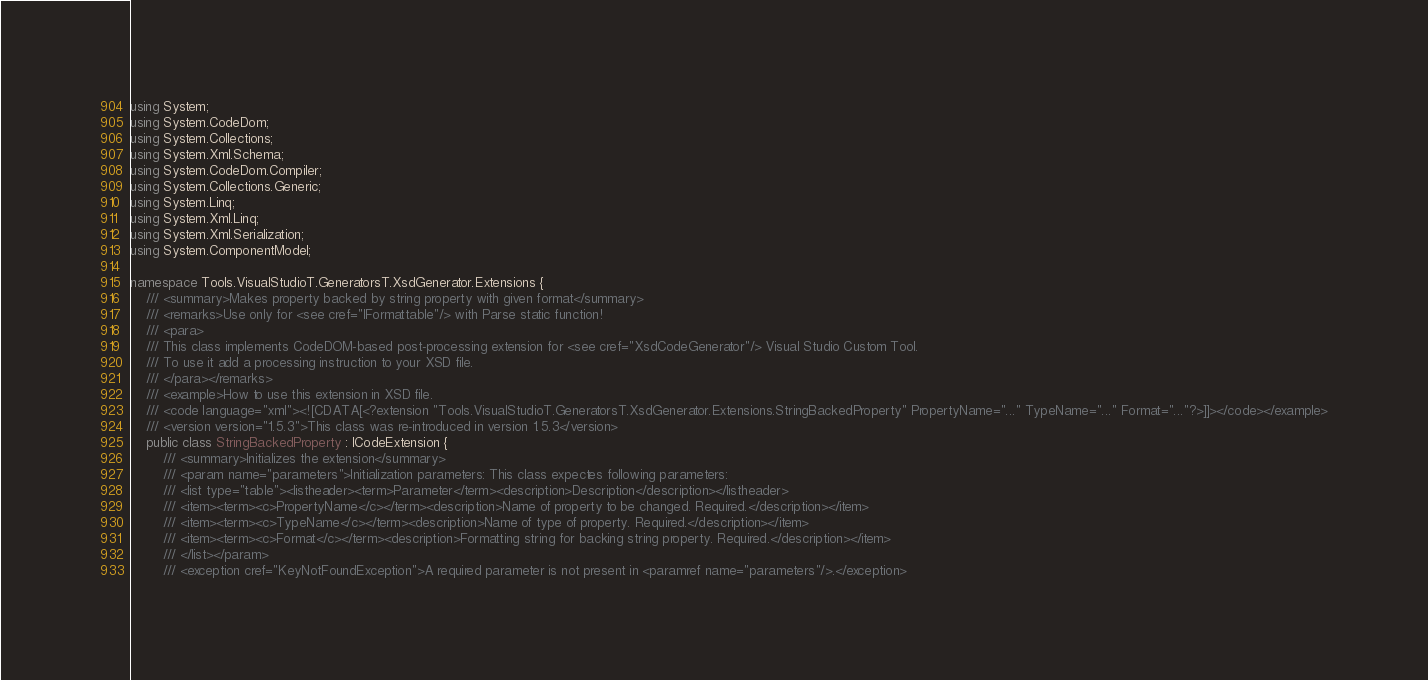Convert code to text. <code><loc_0><loc_0><loc_500><loc_500><_C#_>using System;
using System.CodeDom;
using System.Collections;
using System.Xml.Schema;
using System.CodeDom.Compiler;
using System.Collections.Generic;
using System.Linq;
using System.Xml.Linq;
using System.Xml.Serialization;
using System.ComponentModel;

namespace Tools.VisualStudioT.GeneratorsT.XsdGenerator.Extensions {
    /// <summary>Makes property backed by string property with given format</summary>
    /// <remarks>Use only for <see cref="IFormattable"/> with Parse static function!
    /// <para>
    /// This class implements CodeDOM-based post-processing extension for <see cref="XsdCodeGenerator"/> Visual Studio Custom Tool.
    /// To use it add a processing instruction to your XSD file.
    /// </para></remarks>
    /// <example>How to use this extension in XSD file.
    /// <code language="xml"><![CDATA[<?extension "Tools.VisualStudioT.GeneratorsT.XsdGenerator.Extensions.StringBackedProperty" PropertyName="..." TypeName="..." Format="..."?>]]></code></example>
    /// <version version="1.5.3">This class was re-introduced in version 1.5.3</version>
    public class StringBackedProperty : ICodeExtension {
        /// <summary>Initializes the extension</summary>
        /// <param name="parameters">Initialization parameters: This class expectes following parameters:
        /// <list type="table"><listheader><term>Parameter</term><description>Description</description></listheader>
        /// <item><term><c>PropertyName</c></term><description>Name of property to be changed. Required.</description></item>
        /// <item><term><c>TypeName</c></term><description>Name of type of property. Required.</description></item>
        /// <item><term><c>Format</c></term><description>Formatting string for backing string property. Required.</description></item>
        /// </list></param>
        /// <exception cref="KeyNotFoundException">A required parameter is not present in <paramref name="parameters"/>.</exception></code> 